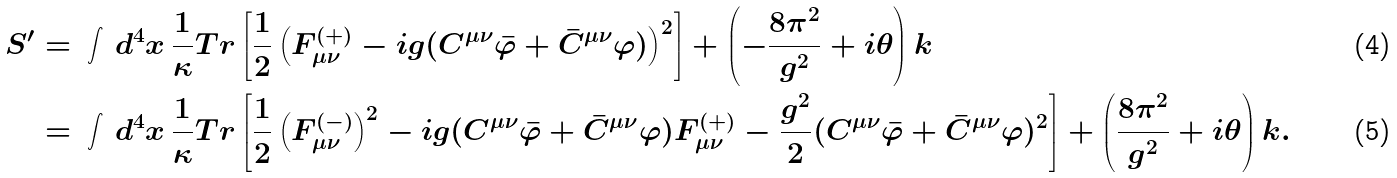<formula> <loc_0><loc_0><loc_500><loc_500>S ^ { \prime } & = \, \int \, d ^ { 4 } x \, \frac { 1 } { \kappa } T r \left [ \frac { 1 } { 2 } \left ( F _ { \mu \nu } ^ { ( + ) } - i g ( C ^ { \mu \nu } \bar { \varphi } + \bar { C } ^ { \mu \nu } \varphi ) \right ) ^ { 2 } \right ] + \left ( - \frac { 8 \pi ^ { 2 } } { g ^ { 2 } } + i \theta \right ) k \\ & = \, \int \, d ^ { 4 } x \, \frac { 1 } { \kappa } T r \left [ \frac { 1 } { 2 } \left ( F _ { \mu \nu } ^ { ( - ) } \right ) ^ { 2 } - i g ( C ^ { \mu \nu } \bar { \varphi } + \bar { C } ^ { \mu \nu } \varphi ) F ^ { ( + ) } _ { \mu \nu } - \frac { g ^ { 2 } } { 2 } ( C ^ { \mu \nu } \bar { \varphi } + \bar { C } ^ { \mu \nu } \varphi ) ^ { 2 } \right ] + \left ( \frac { 8 \pi ^ { 2 } } { g ^ { 2 } } + i \theta \right ) k .</formula> 